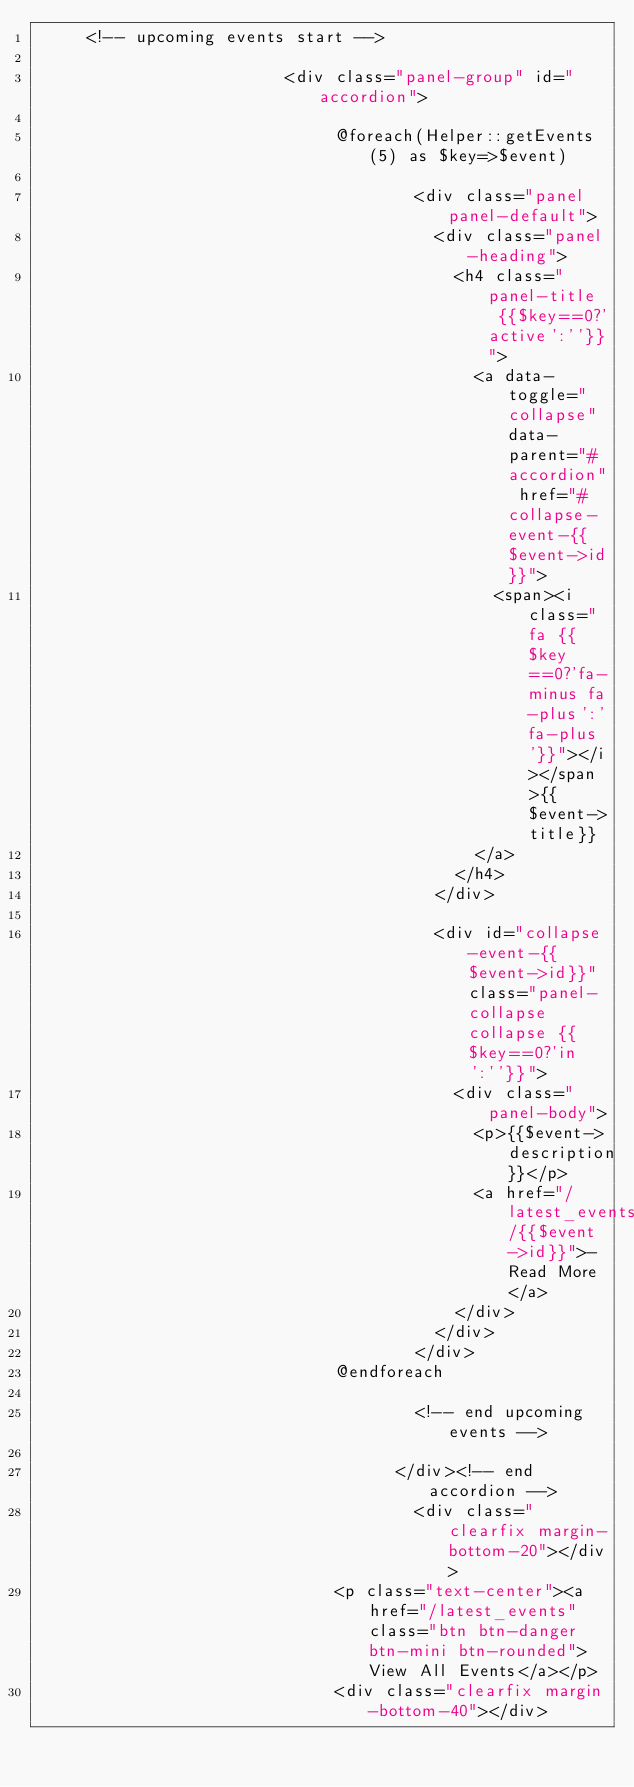Convert code to text. <code><loc_0><loc_0><loc_500><loc_500><_PHP_>     <!-- upcoming events start -->

                         <div class="panel-group" id="accordion">
                                  
                              @foreach(Helper::getEvents(5) as $key=>$event)
                                  
                                      <div class="panel panel-default">
                                        <div class="panel-heading">
                                          <h4 class="panel-title  {{$key==0?'active':''}}">
                                            <a data-toggle="collapse" data-parent="#accordion" href="#collapse-event-{{$event->id}}">
                                              <span><i class="fa {{$key==0?'fa-minus fa-plus':'fa-plus'}}"></i></span>{{$event->title}}
                                            </a>
                                          </h4>
                                        </div>
                                        
                                        <div id="collapse-event-{{$event->id}}" class="panel-collapse collapse {{$key==0?'in':''}}">
                                          <div class="panel-body">
                                            <p>{{$event->description}}</p>
                                            <a href="/latest_events/{{$event->id}}">- Read More</a>
                                          </div>
                                        </div>
                                      </div>
                              @endforeach
                                    
                                      <!-- end upcoming events -->
                                      
                                    </div><!-- end accordion -->
                                      <div class="clearfix margin-bottom-20"></div>
                              <p class="text-center"><a href="/latest_events" class="btn btn-danger btn-mini btn-rounded">View All Events</a></p>
                              <div class="clearfix margin-bottom-40"></div></code> 